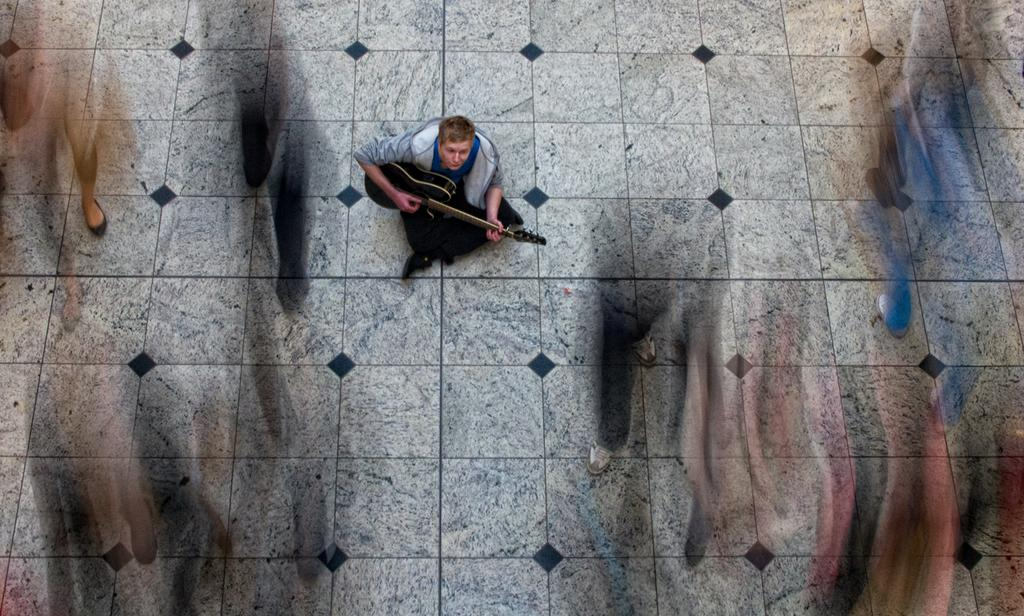What is the man in the image doing? The man is sitting on the floor and playing a musical instrument. Can you describe the actions of the other people in the image? There are persons walking in the image, but they are blurred. What might be the reason for the blurred appearance of the walking persons? The blurred appearance of the walking persons might be due to their movement while the image was taken. What type of yoke is being used by the man in the image? There is no yoke present in the image; the man is playing a musical instrument. How is the pen distributed among the persons in the image? There is no pen present in the image, so it cannot be distributed among the persons. 